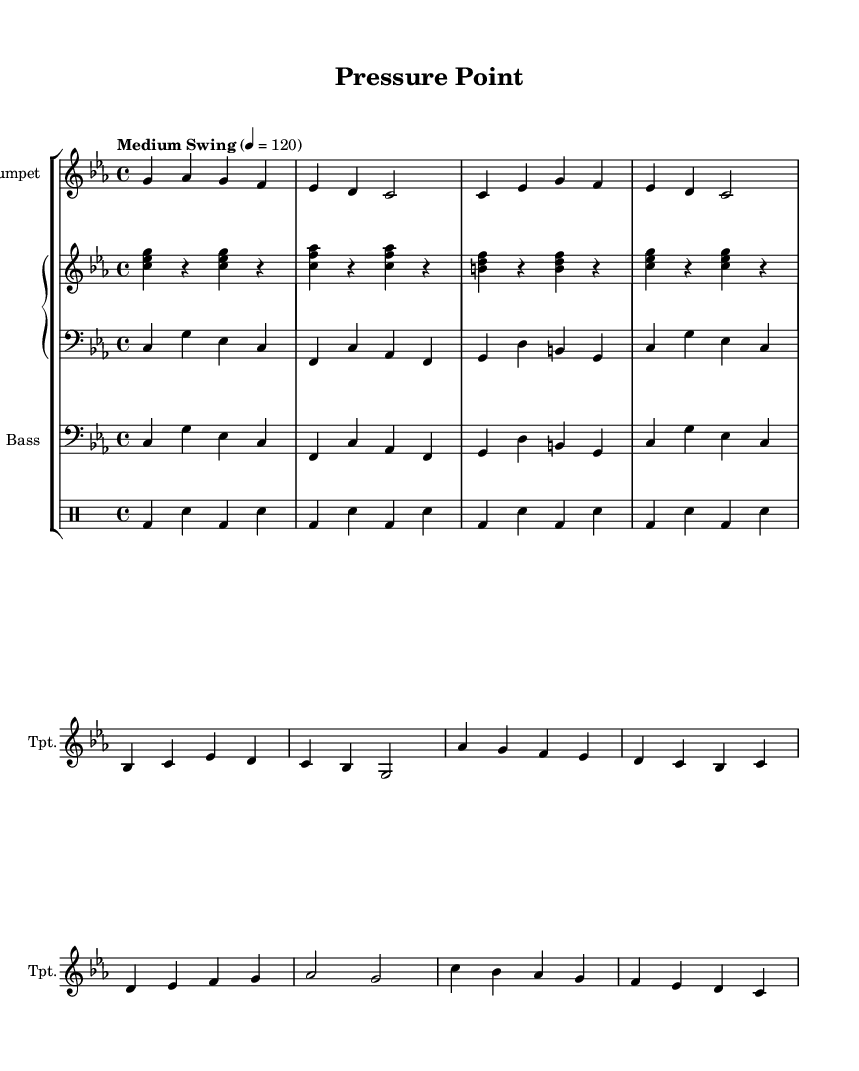What is the key signature of this music? The key signature is indicated at the beginning of the score and reflects that there are three flats, which is characteristic of C minor.
Answer: C minor What is the time signature of this music? The time signature appears next to the key signature at the start of the piece and shows that it is in 4/4 time, meaning there are four beats in each measure.
Answer: 4/4 What is the tempo marking of this piece? The tempo marking is provided in the score and indicates the speed of the music, which is "Medium Swing" at a metronome marking of 120 beats per minute.
Answer: Medium Swing, 120 How many measures are in the A Section? The A Section consists of two phrases with a total of eight measures, as indicated in the music.
Answer: 8 measures What instruments are included in this composition? The instrumentation is shown at the beginning of the score and includes a trumpet, piano (with right and left hand parts), bass, and drums.
Answer: Trumpet, piano, bass, drums Which section features a walking bass line? The bass part throughout the piece follows a walking bass pattern, which is characteristic of jazz, and is evident in the bass staff in both the A and B sections.
Answer: Bass In which section does the trumpet begin playing? The trumpet starts playing from the introduction, transitioning into the A Section, indicated by the distinct musical line beginning after the intro notes.
Answer: Introduction 